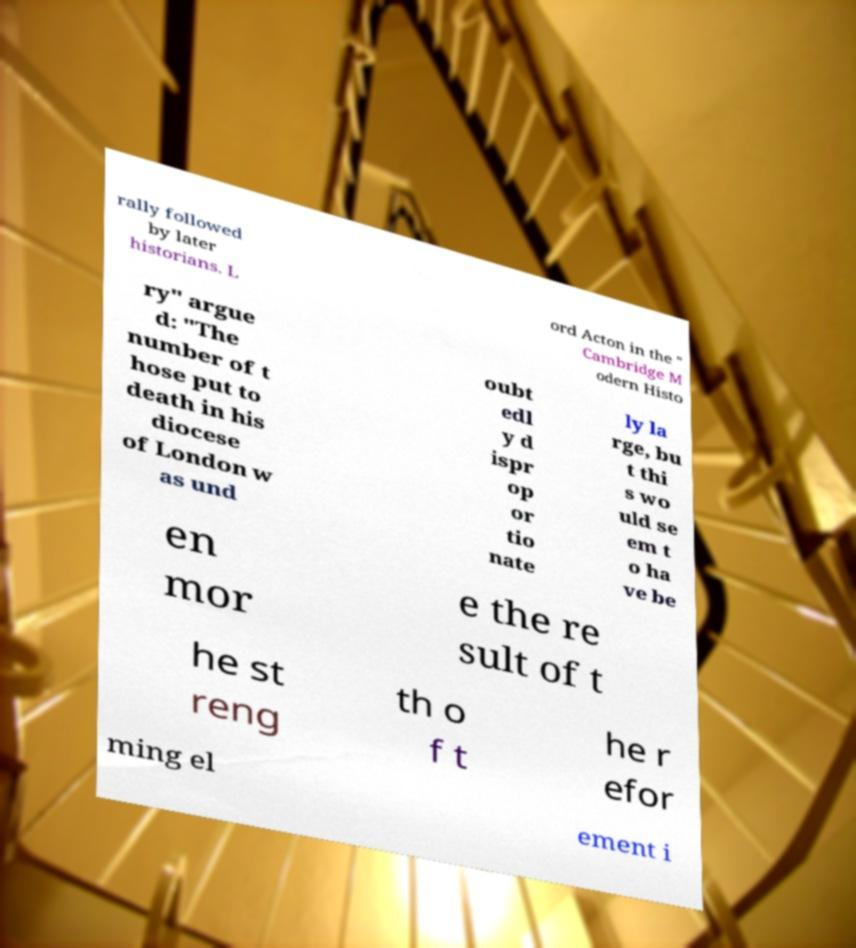Please identify and transcribe the text found in this image. rally followed by later historians. L ord Acton in the " Cambridge M odern Histo ry" argue d: "The number of t hose put to death in his diocese of London w as und oubt edl y d ispr op or tio nate ly la rge, bu t thi s wo uld se em t o ha ve be en mor e the re sult of t he st reng th o f t he r efor ming el ement i 